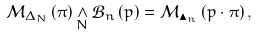Convert formula to latex. <formula><loc_0><loc_0><loc_500><loc_500>\mathcal { M } _ { \Delta _ { N } } \left ( \pi \right ) \underset { N } { \wedge } \mathcal { B } _ { n } \left ( p \right ) = \mathcal { M } _ { \blacktriangle _ { n } } \left ( p \cdot \pi \right ) ,</formula> 